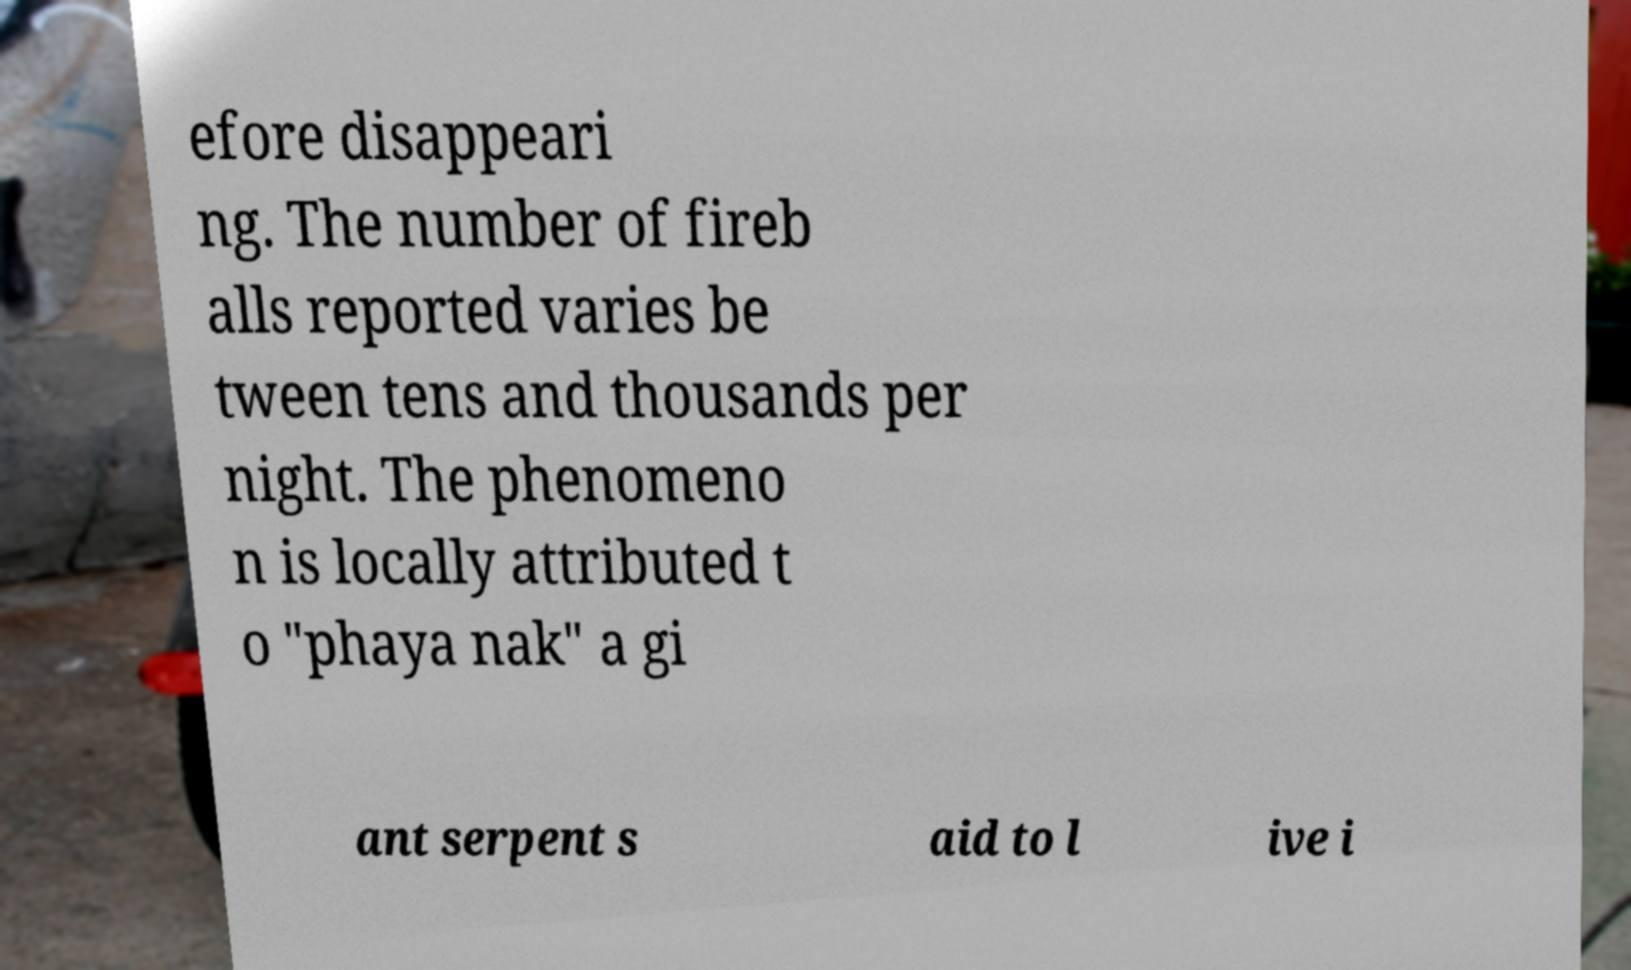There's text embedded in this image that I need extracted. Can you transcribe it verbatim? efore disappeari ng. The number of fireb alls reported varies be tween tens and thousands per night. The phenomeno n is locally attributed t o "phaya nak" a gi ant serpent s aid to l ive i 